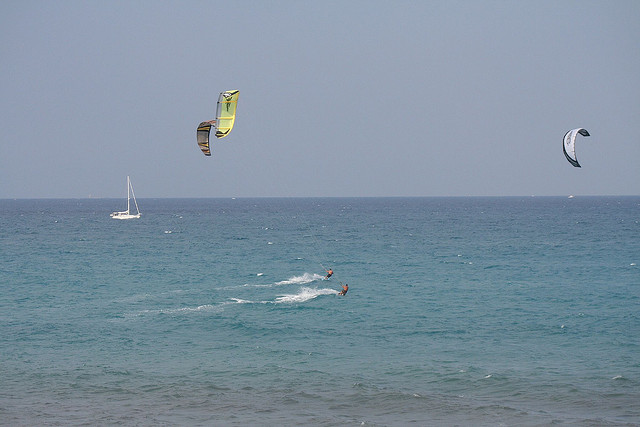What sport are the two people in the water participating in?
A. sailing
B. swimming
C. para waterskiing
D. surfing
Answer with the option's letter from the given choices directly. The two individuals in the image are engaged in the sport of kitesurfing, which is not listed in the provided options. Kitesurfing is an action sport combining aspects of wakeboarding, snowboarding, windsurfing, surfing, paragliding, skateboarding, and sailing into one extreme sport. The kitesurfers use the wind power from the large controllable kites to be pulled on the water on a kitesurf board. Therefore, the correct answer that closely matches from the given choices would be C, para waterskiing, because it includes an aspect of being towed on water, although it's not the precise sport depicted. 